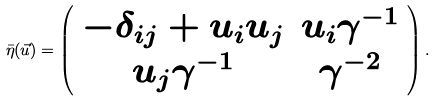Convert formula to latex. <formula><loc_0><loc_0><loc_500><loc_500>\bar { \eta } ( \vec { u } ) = \left ( \begin{array} { c c } - \delta _ { i j } + u _ { i } u _ { j } & u _ { i } \gamma ^ { - 1 } \\ u _ { j } \gamma ^ { - 1 } & \gamma ^ { - 2 } \\ \end{array} \right ) .</formula> 